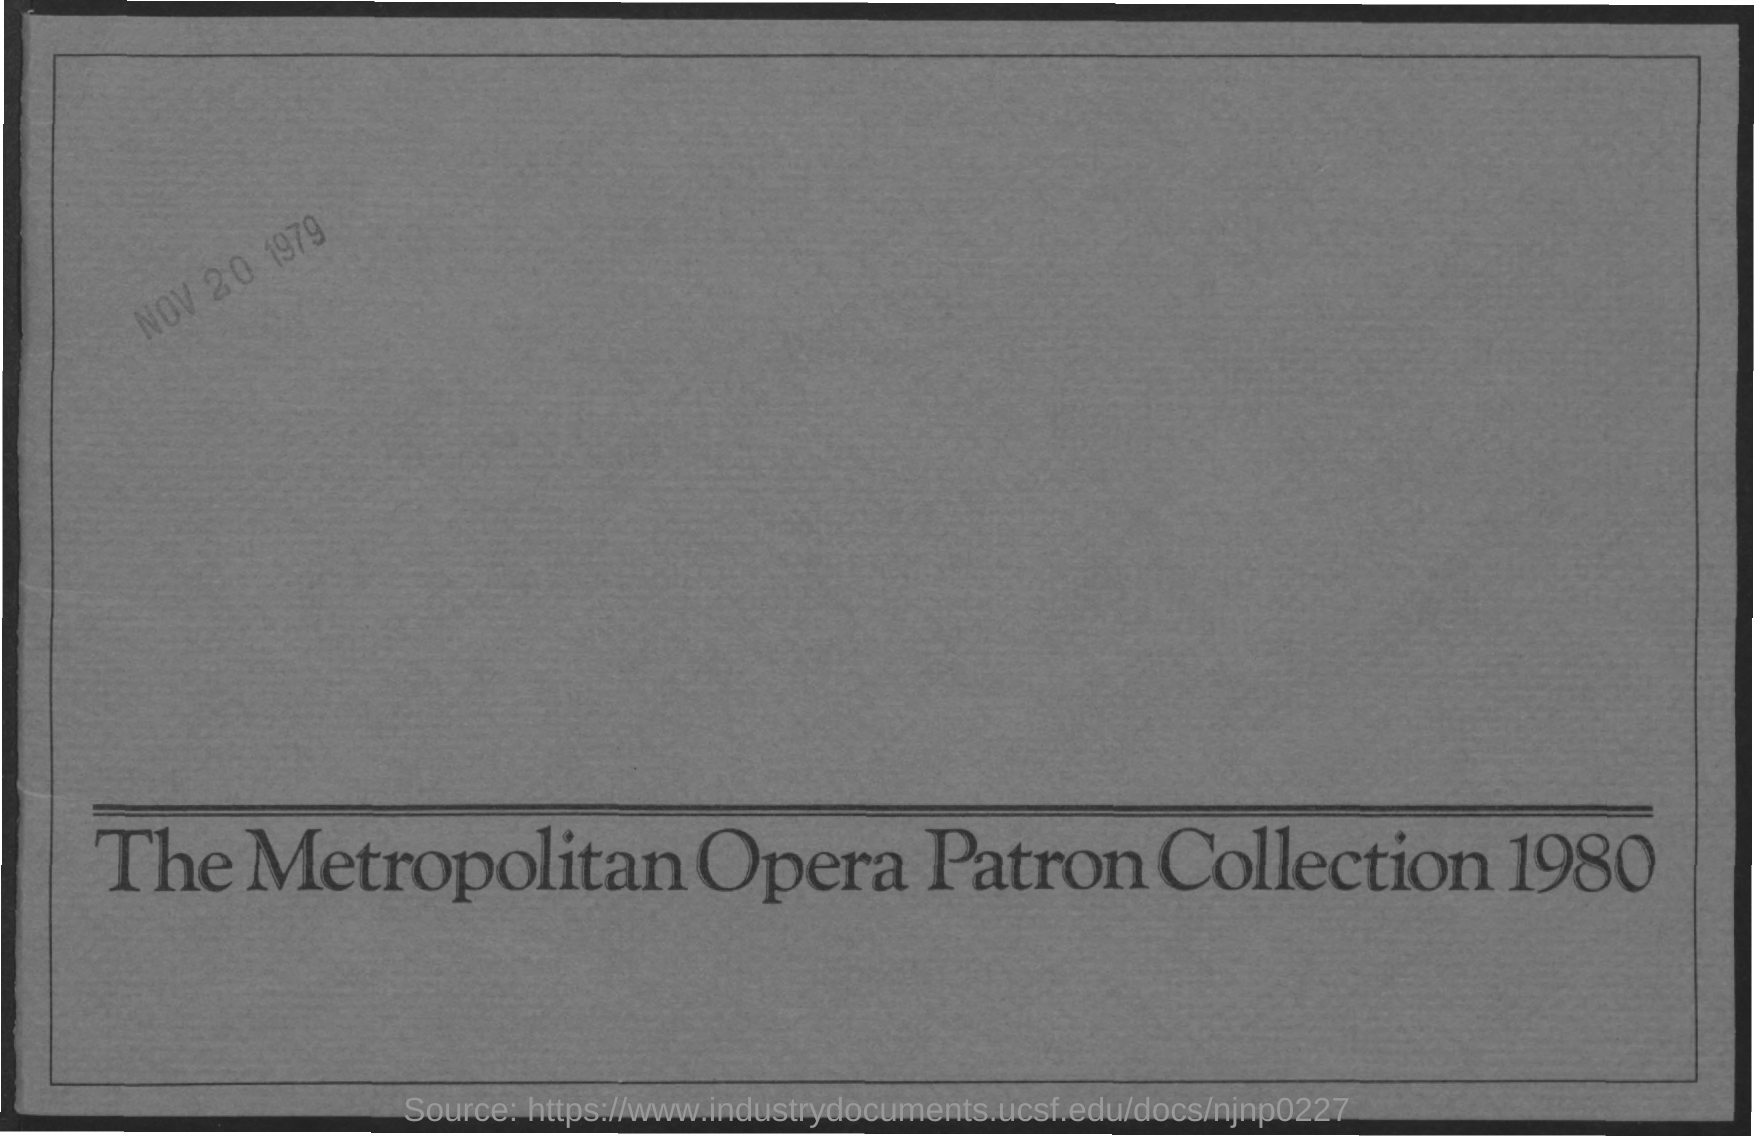Indicate a few pertinent items in this graphic. The document title is "The Metropolitan Opera Patron Collection 1980. The document is dated November 20, 1979. 